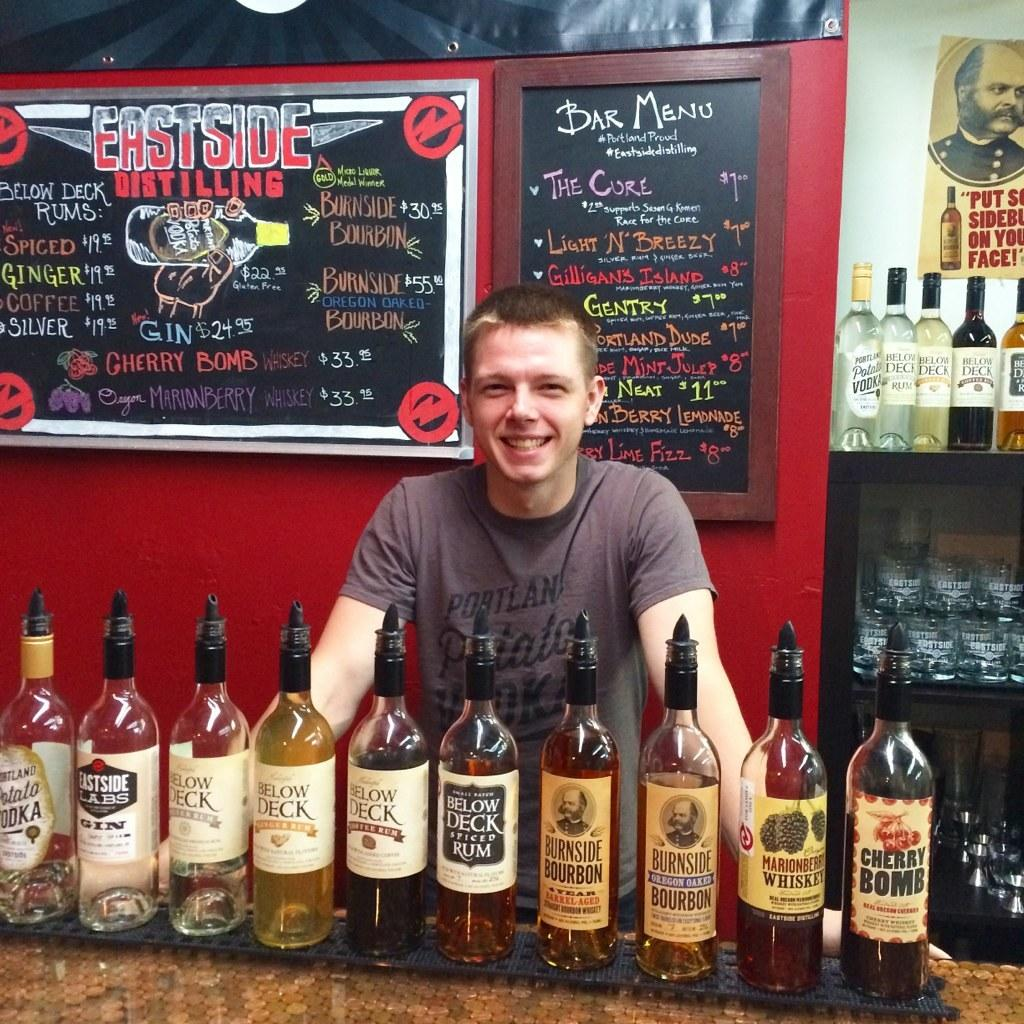<image>
Render a clear and concise summary of the photo. A ma posing at a bar with Burnside Bourbon in front of him. 